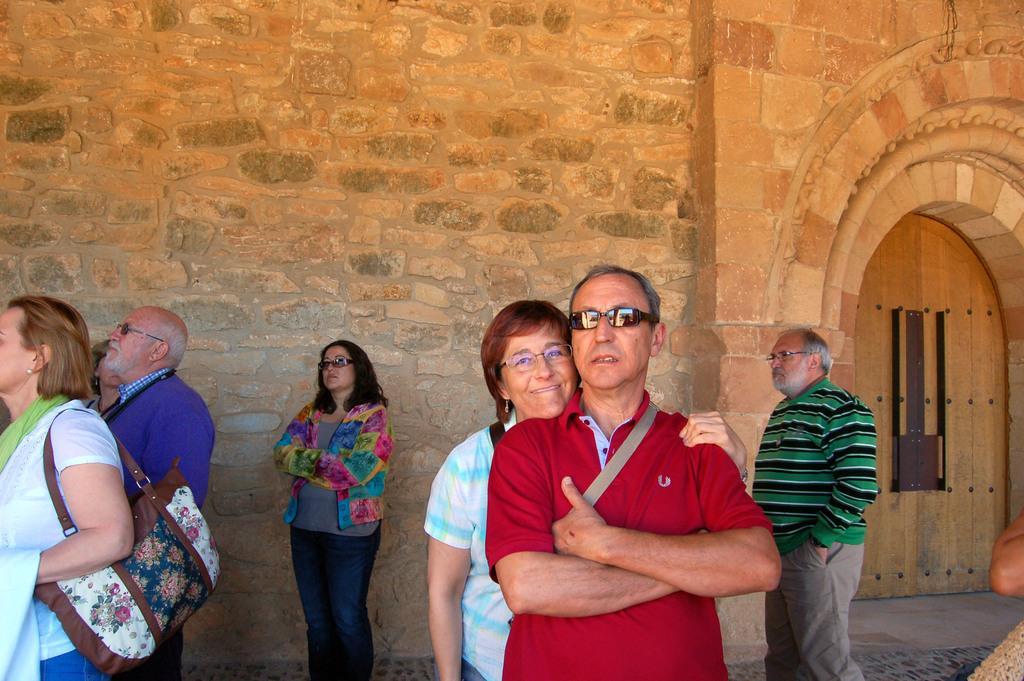How would you summarize this image in a sentence or two? In this image, we can see persons wearing clothes. There is a door on the right side of the image. In the background, we can see a wall. 